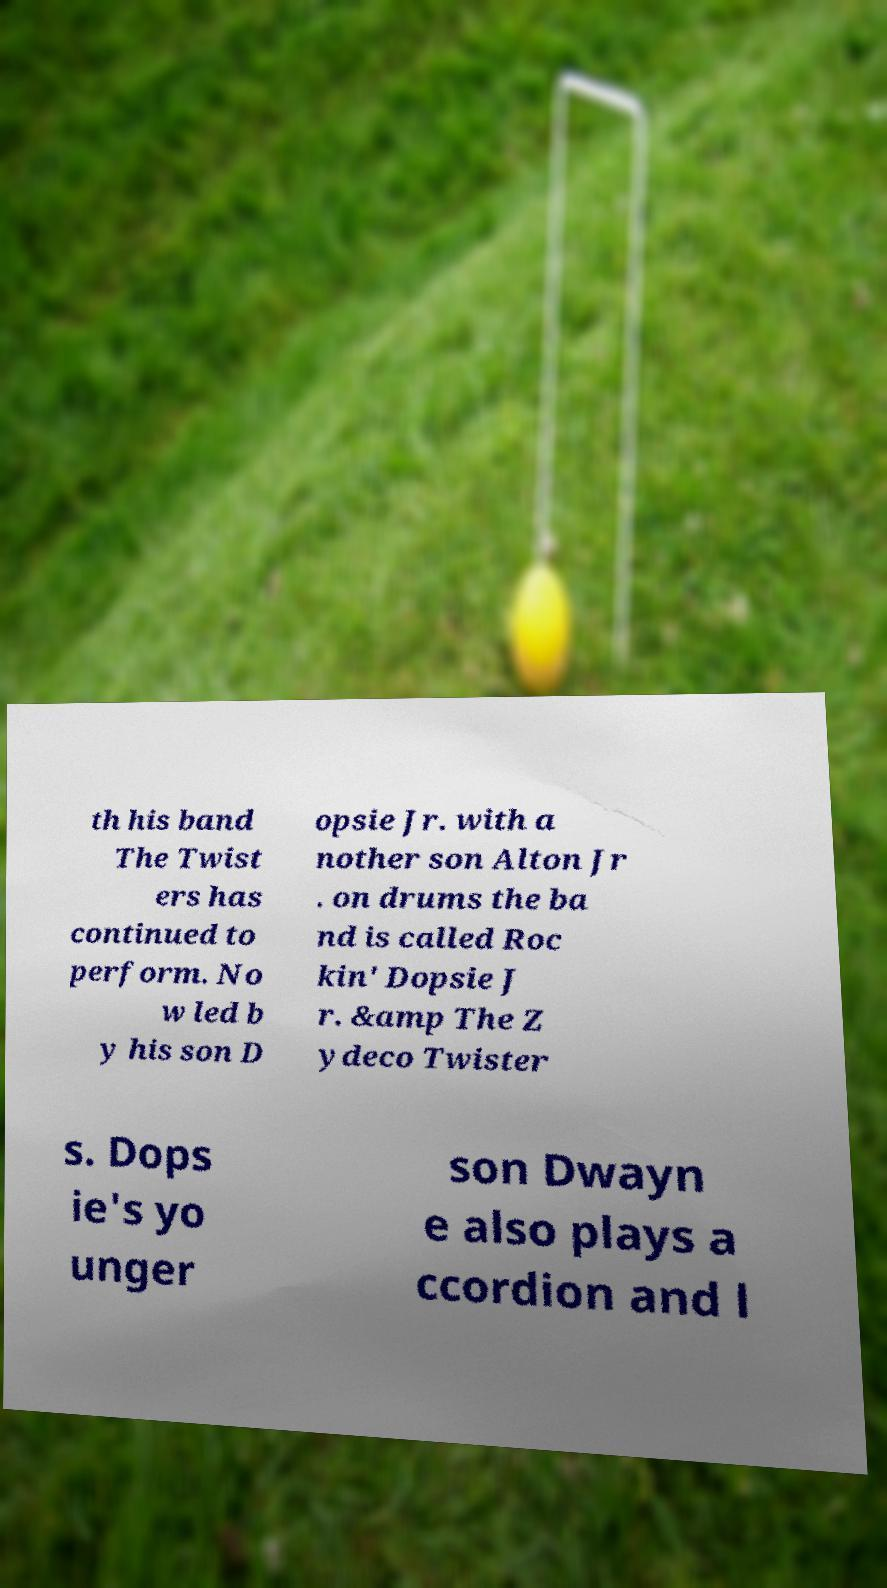Could you assist in decoding the text presented in this image and type it out clearly? th his band The Twist ers has continued to perform. No w led b y his son D opsie Jr. with a nother son Alton Jr . on drums the ba nd is called Roc kin' Dopsie J r. &amp The Z ydeco Twister s. Dops ie's yo unger son Dwayn e also plays a ccordion and l 